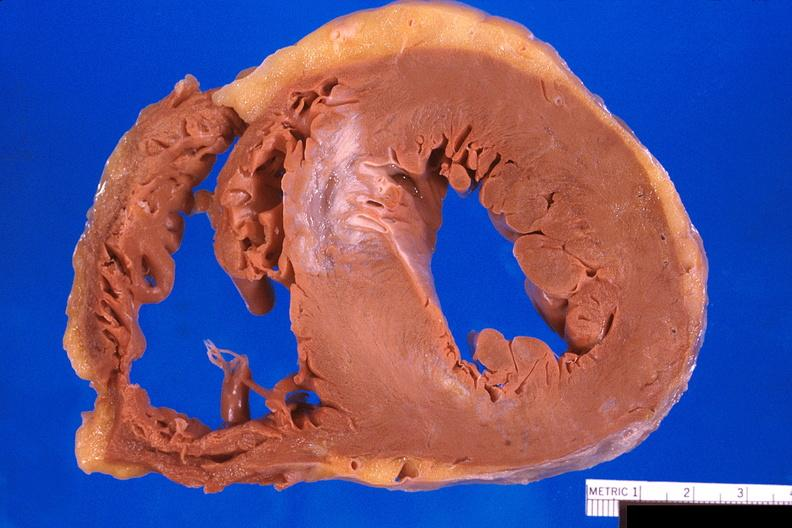where is this?
Answer the question using a single word or phrase. Heart 